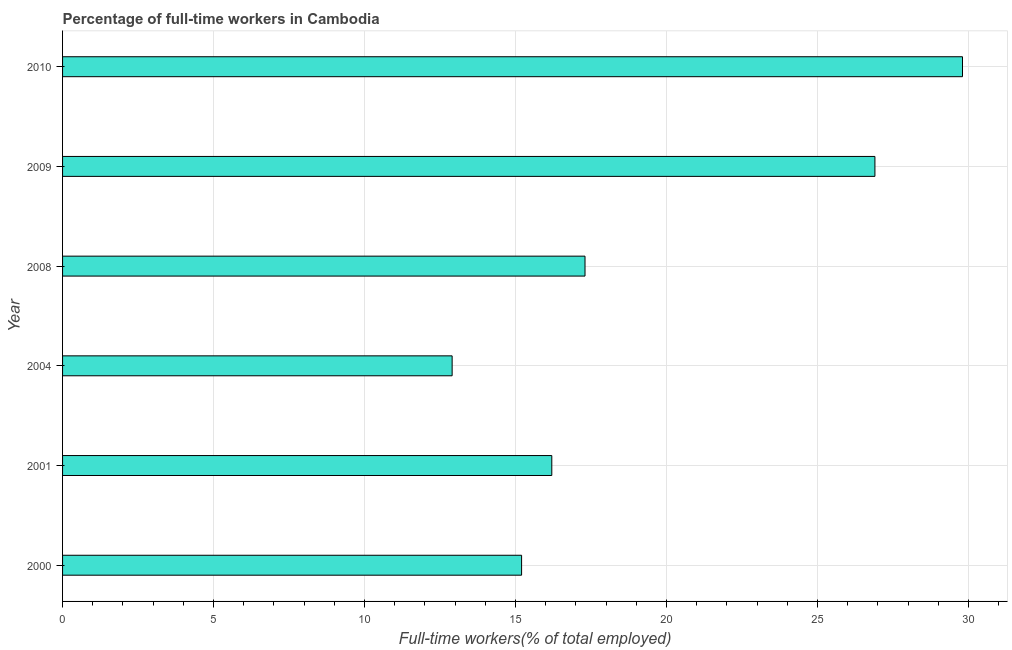Does the graph contain any zero values?
Offer a very short reply. No. What is the title of the graph?
Make the answer very short. Percentage of full-time workers in Cambodia. What is the label or title of the X-axis?
Your answer should be compact. Full-time workers(% of total employed). What is the label or title of the Y-axis?
Provide a short and direct response. Year. What is the percentage of full-time workers in 2008?
Your answer should be compact. 17.3. Across all years, what is the maximum percentage of full-time workers?
Your answer should be very brief. 29.8. Across all years, what is the minimum percentage of full-time workers?
Your response must be concise. 12.9. In which year was the percentage of full-time workers maximum?
Provide a short and direct response. 2010. What is the sum of the percentage of full-time workers?
Provide a short and direct response. 118.3. What is the difference between the percentage of full-time workers in 2004 and 2008?
Make the answer very short. -4.4. What is the average percentage of full-time workers per year?
Give a very brief answer. 19.72. What is the median percentage of full-time workers?
Your response must be concise. 16.75. In how many years, is the percentage of full-time workers greater than 15 %?
Offer a very short reply. 5. What is the ratio of the percentage of full-time workers in 2009 to that in 2010?
Give a very brief answer. 0.9. Is the percentage of full-time workers in 2004 less than that in 2008?
Make the answer very short. Yes. What is the difference between the highest and the second highest percentage of full-time workers?
Provide a succinct answer. 2.9. In how many years, is the percentage of full-time workers greater than the average percentage of full-time workers taken over all years?
Keep it short and to the point. 2. How many years are there in the graph?
Give a very brief answer. 6. Are the values on the major ticks of X-axis written in scientific E-notation?
Offer a very short reply. No. What is the Full-time workers(% of total employed) in 2000?
Ensure brevity in your answer.  15.2. What is the Full-time workers(% of total employed) in 2001?
Give a very brief answer. 16.2. What is the Full-time workers(% of total employed) of 2004?
Ensure brevity in your answer.  12.9. What is the Full-time workers(% of total employed) in 2008?
Provide a short and direct response. 17.3. What is the Full-time workers(% of total employed) in 2009?
Offer a terse response. 26.9. What is the Full-time workers(% of total employed) of 2010?
Offer a terse response. 29.8. What is the difference between the Full-time workers(% of total employed) in 2000 and 2001?
Keep it short and to the point. -1. What is the difference between the Full-time workers(% of total employed) in 2000 and 2009?
Give a very brief answer. -11.7. What is the difference between the Full-time workers(% of total employed) in 2000 and 2010?
Provide a succinct answer. -14.6. What is the difference between the Full-time workers(% of total employed) in 2004 and 2010?
Your response must be concise. -16.9. What is the difference between the Full-time workers(% of total employed) in 2008 and 2009?
Ensure brevity in your answer.  -9.6. What is the difference between the Full-time workers(% of total employed) in 2008 and 2010?
Your answer should be very brief. -12.5. What is the difference between the Full-time workers(% of total employed) in 2009 and 2010?
Offer a very short reply. -2.9. What is the ratio of the Full-time workers(% of total employed) in 2000 to that in 2001?
Provide a succinct answer. 0.94. What is the ratio of the Full-time workers(% of total employed) in 2000 to that in 2004?
Ensure brevity in your answer.  1.18. What is the ratio of the Full-time workers(% of total employed) in 2000 to that in 2008?
Your answer should be compact. 0.88. What is the ratio of the Full-time workers(% of total employed) in 2000 to that in 2009?
Your response must be concise. 0.56. What is the ratio of the Full-time workers(% of total employed) in 2000 to that in 2010?
Keep it short and to the point. 0.51. What is the ratio of the Full-time workers(% of total employed) in 2001 to that in 2004?
Make the answer very short. 1.26. What is the ratio of the Full-time workers(% of total employed) in 2001 to that in 2008?
Keep it short and to the point. 0.94. What is the ratio of the Full-time workers(% of total employed) in 2001 to that in 2009?
Provide a short and direct response. 0.6. What is the ratio of the Full-time workers(% of total employed) in 2001 to that in 2010?
Ensure brevity in your answer.  0.54. What is the ratio of the Full-time workers(% of total employed) in 2004 to that in 2008?
Ensure brevity in your answer.  0.75. What is the ratio of the Full-time workers(% of total employed) in 2004 to that in 2009?
Keep it short and to the point. 0.48. What is the ratio of the Full-time workers(% of total employed) in 2004 to that in 2010?
Your answer should be compact. 0.43. What is the ratio of the Full-time workers(% of total employed) in 2008 to that in 2009?
Provide a short and direct response. 0.64. What is the ratio of the Full-time workers(% of total employed) in 2008 to that in 2010?
Make the answer very short. 0.58. What is the ratio of the Full-time workers(% of total employed) in 2009 to that in 2010?
Your answer should be compact. 0.9. 